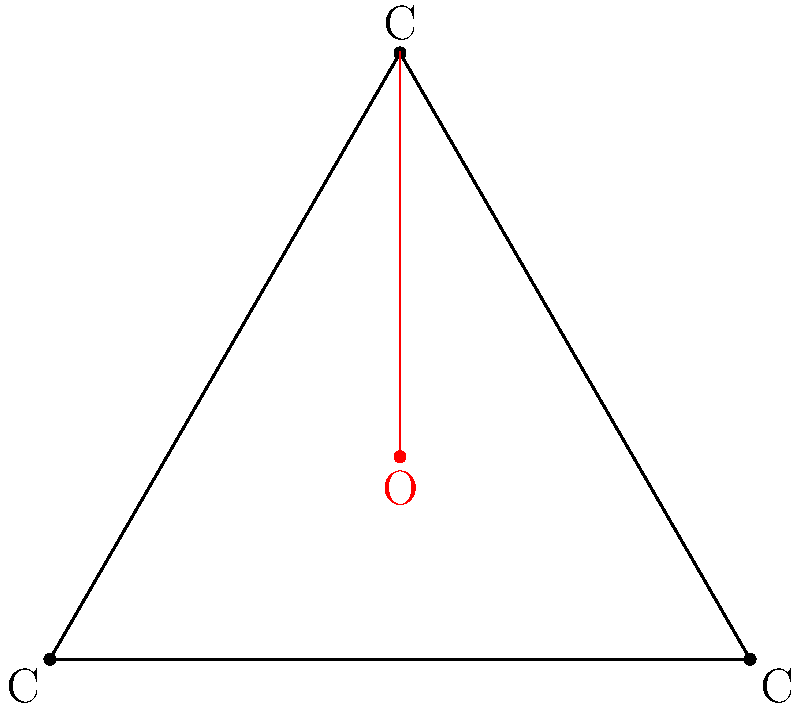In the simplified molecular structure diagram of graphene oxide shown above, what is the hybridization state of the carbon atom bonded to the oxygen atom, and how does this affect the overall structure compared to pristine graphene? 1. Examine the diagram:
   - Three carbon atoms form a triangular arrangement, typical of graphene's hexagonal structure.
   - One oxygen atom is bonded to one of the carbon atoms.

2. Analyze the carbon atom bonded to oxygen:
   - In pristine graphene, carbon atoms are $sp^2$ hybridized, forming three $\sigma$ bonds in a planar arrangement.
   - The presence of the oxygen atom indicates a change in hybridization for the bonded carbon.

3. Determine the new hybridization state:
   - The carbon atom bonded to oxygen now forms four bonds: three to neighboring carbons and one to oxygen.
   - This suggests a change to $sp^3$ hybridization, which allows for tetrahedral bonding.

4. Consider the structural implications:
   - $sp^3$ hybridization causes the carbon atom to adopt a slightly pyramidal geometry.
   - This deviation from planarity introduces local distortions in the graphene sheet.

5. Compare to pristine graphene:
   - Pristine graphene is entirely planar with $sp^2$ hybridized carbons.
   - The introduction of $sp^3$ carbons in graphene oxide leads to:
     a) Increased layer spacing
     b) Wrinkles and ripples in the sheet
     c) Modified electronic properties due to disrupted $\pi$-conjugation

6. Conclude the overall effect:
   - The change in hybridization from $sp^2$ to $sp^3$ for the carbon bonded to oxygen results in local structural distortions and alters the material's properties compared to pristine graphene.
Answer: $sp^3$ hybridization; introduces local distortions and alters planarity 